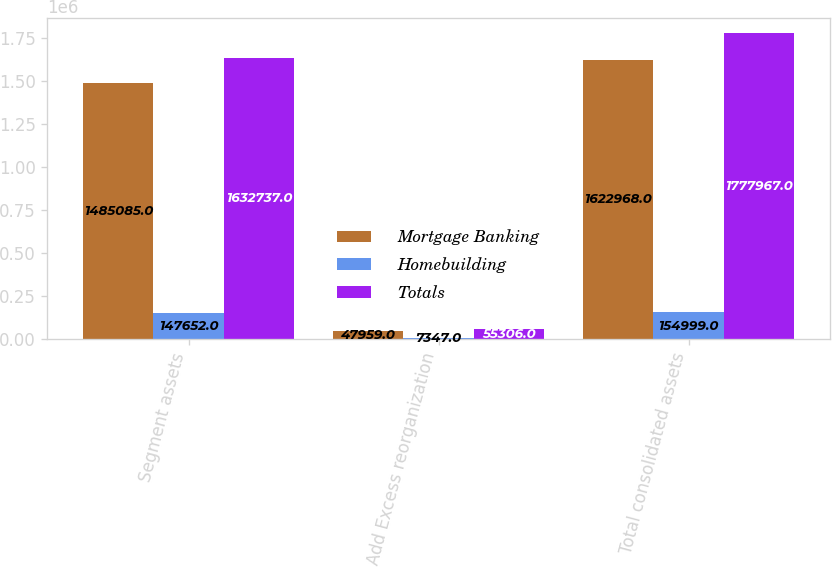<chart> <loc_0><loc_0><loc_500><loc_500><stacked_bar_chart><ecel><fcel>Segment assets<fcel>Add Excess reorganization<fcel>Total consolidated assets<nl><fcel>Mortgage Banking<fcel>1.48508e+06<fcel>47959<fcel>1.62297e+06<nl><fcel>Homebuilding<fcel>147652<fcel>7347<fcel>154999<nl><fcel>Totals<fcel>1.63274e+06<fcel>55306<fcel>1.77797e+06<nl></chart> 